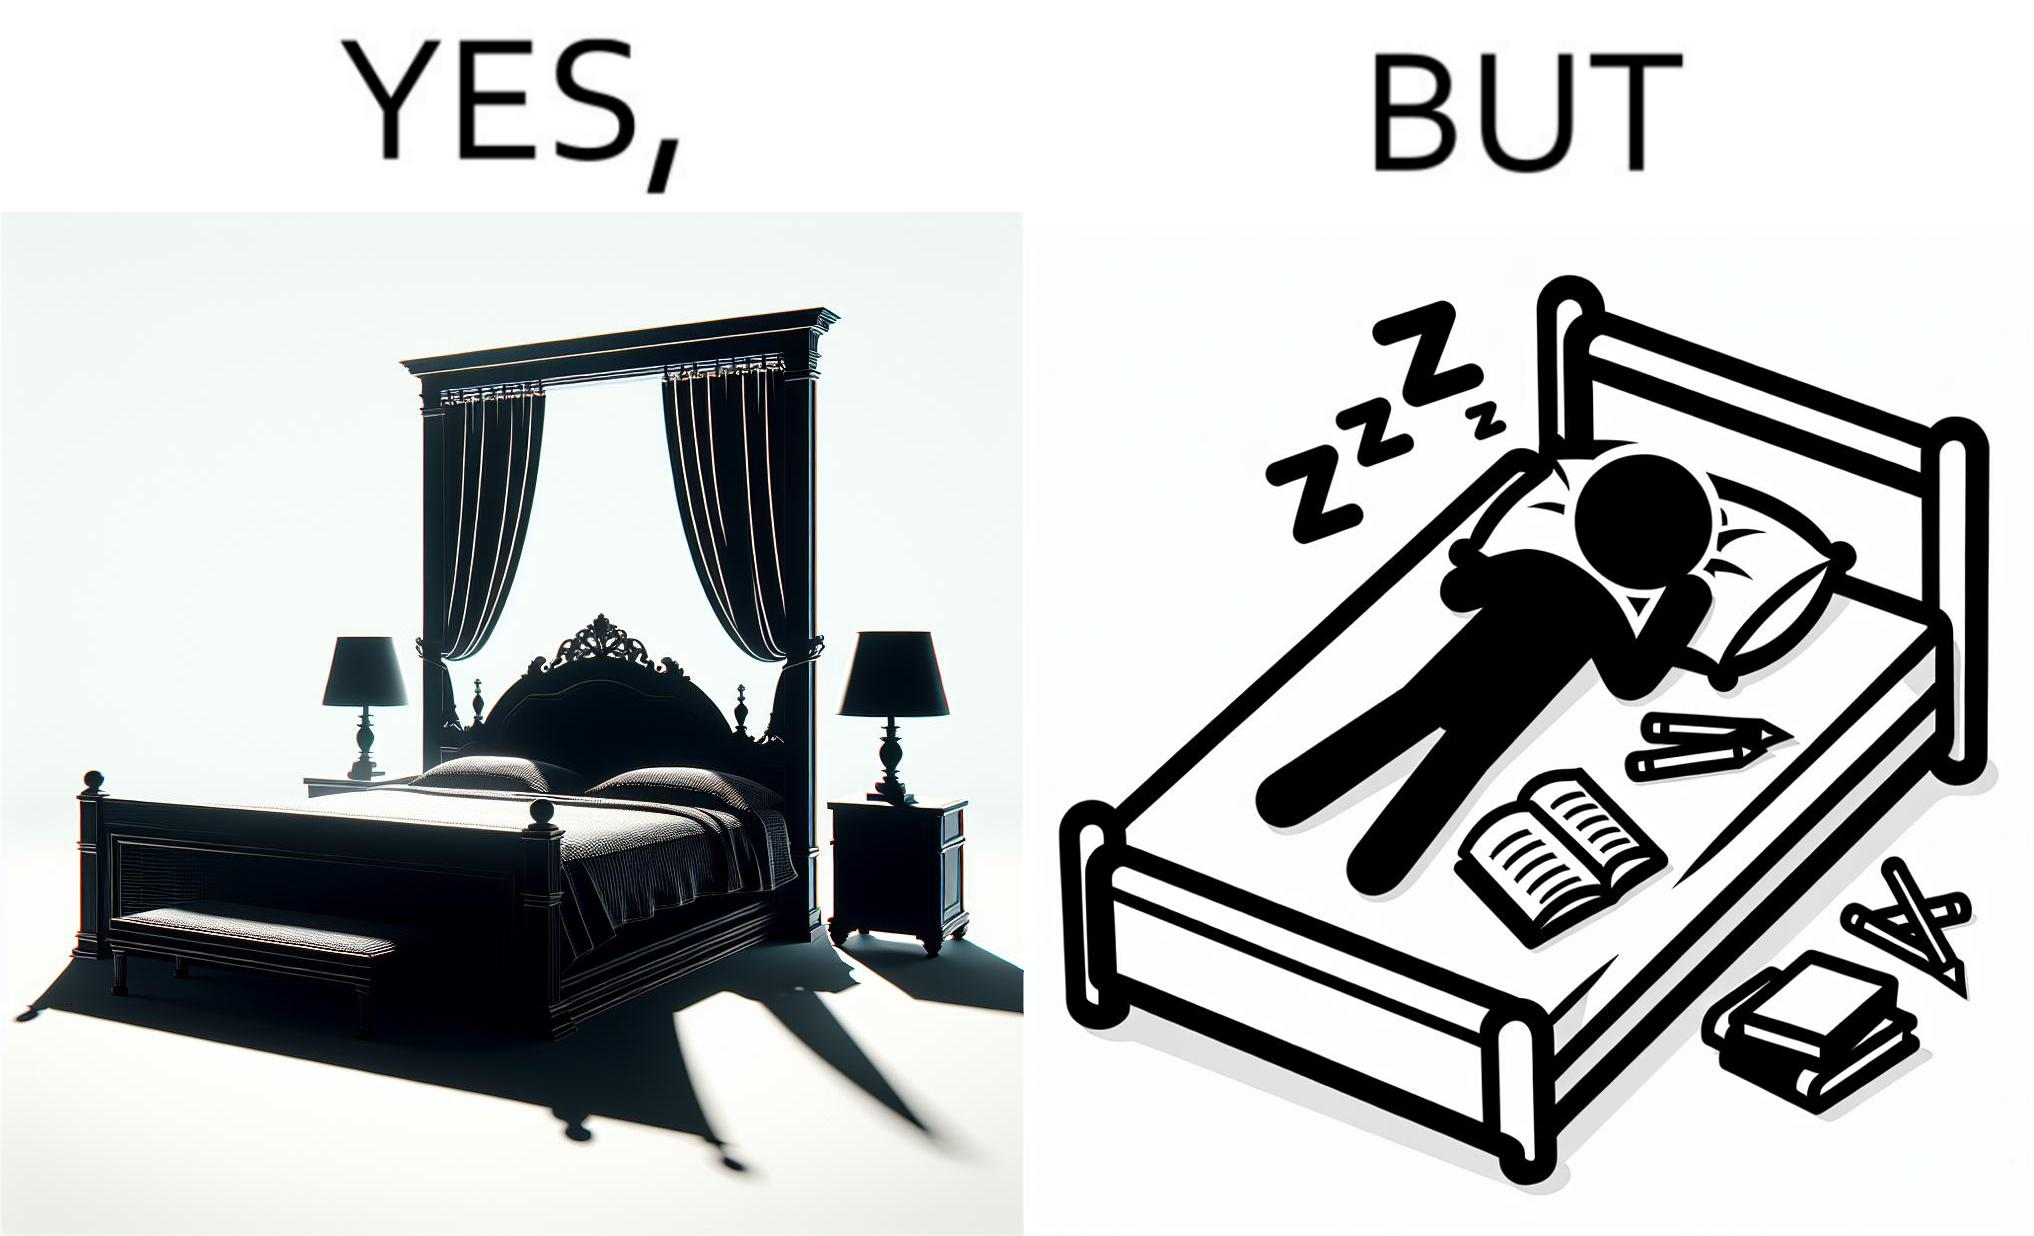Explain the humor or irony in this image. Although the person has purchased a king size bed, but only less than half of the space is used by the person for sleeping. 